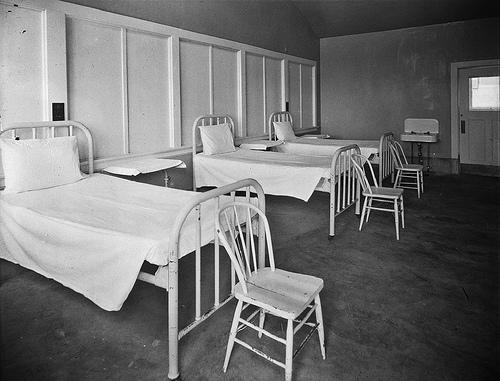This room looks like an old type of what?

Choices:
A) school
B) church
C) hospital
D) prison hospital 